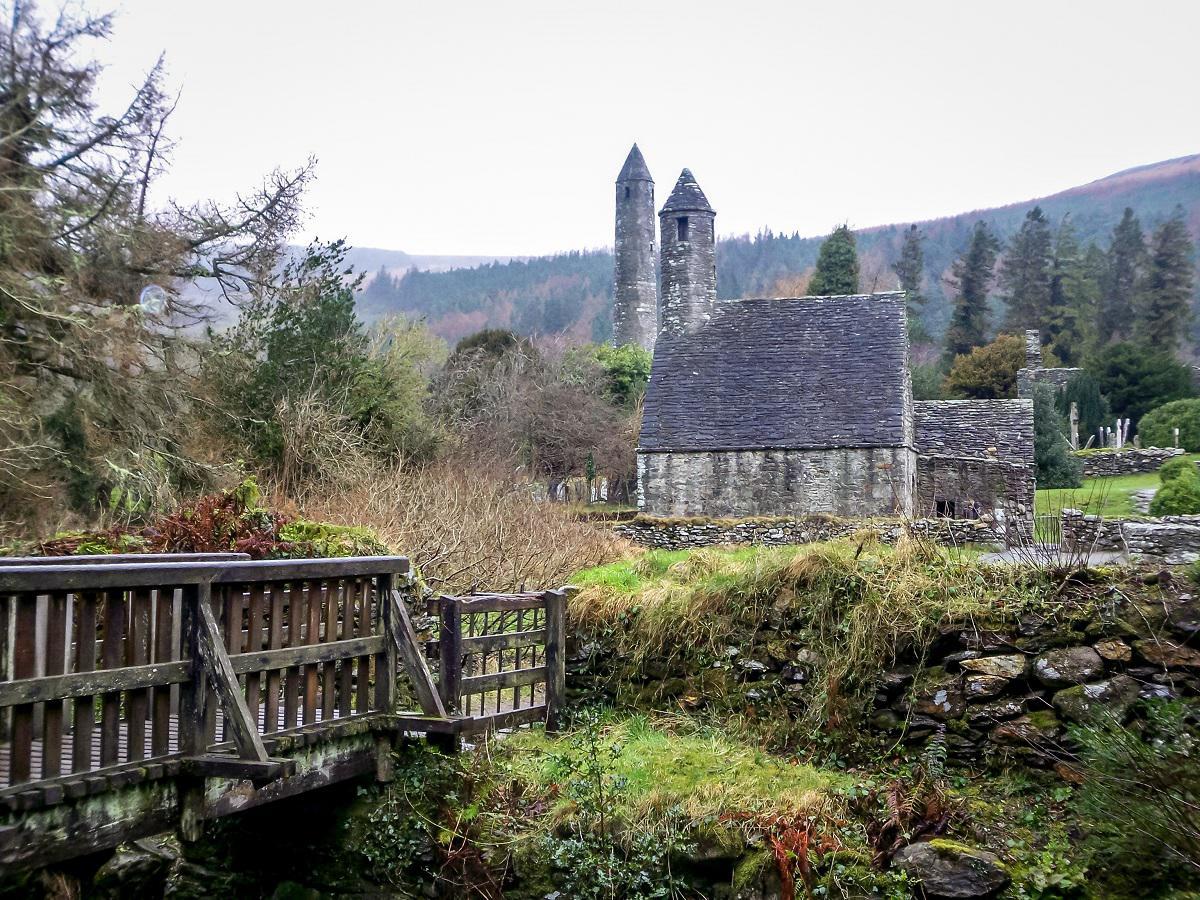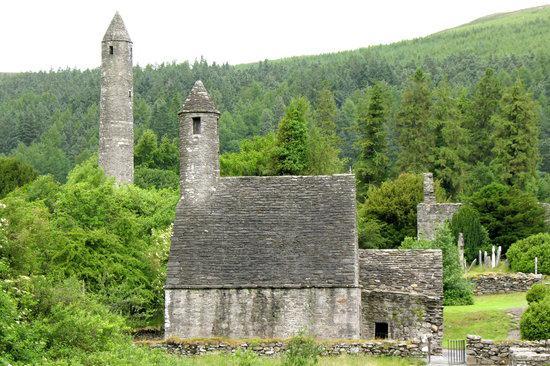The first image is the image on the left, the second image is the image on the right. Given the left and right images, does the statement "An image shows an old gray building featuring a cone-topped tower in the foreground, with no water or bridge visible." hold true? Answer yes or no. Yes. 